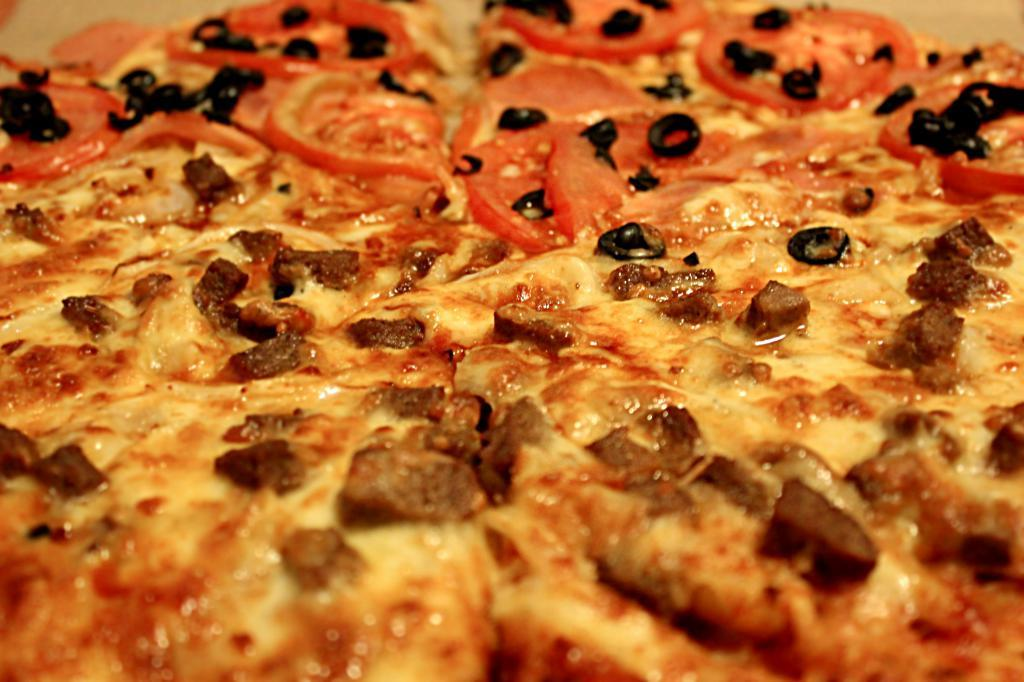What type of food is the main subject of the image? There is a pizza in the image. Can you describe the pizza in the image? The provided facts do not give any details about the pizza's appearance or toppings. Is there anything else visible in the image besides the pizza? The provided facts do not mention any other objects or subjects in the image. How much money is being exchanged for the pizza in the image? There is no information about money or any transaction in the image; it only shows a pizza. 